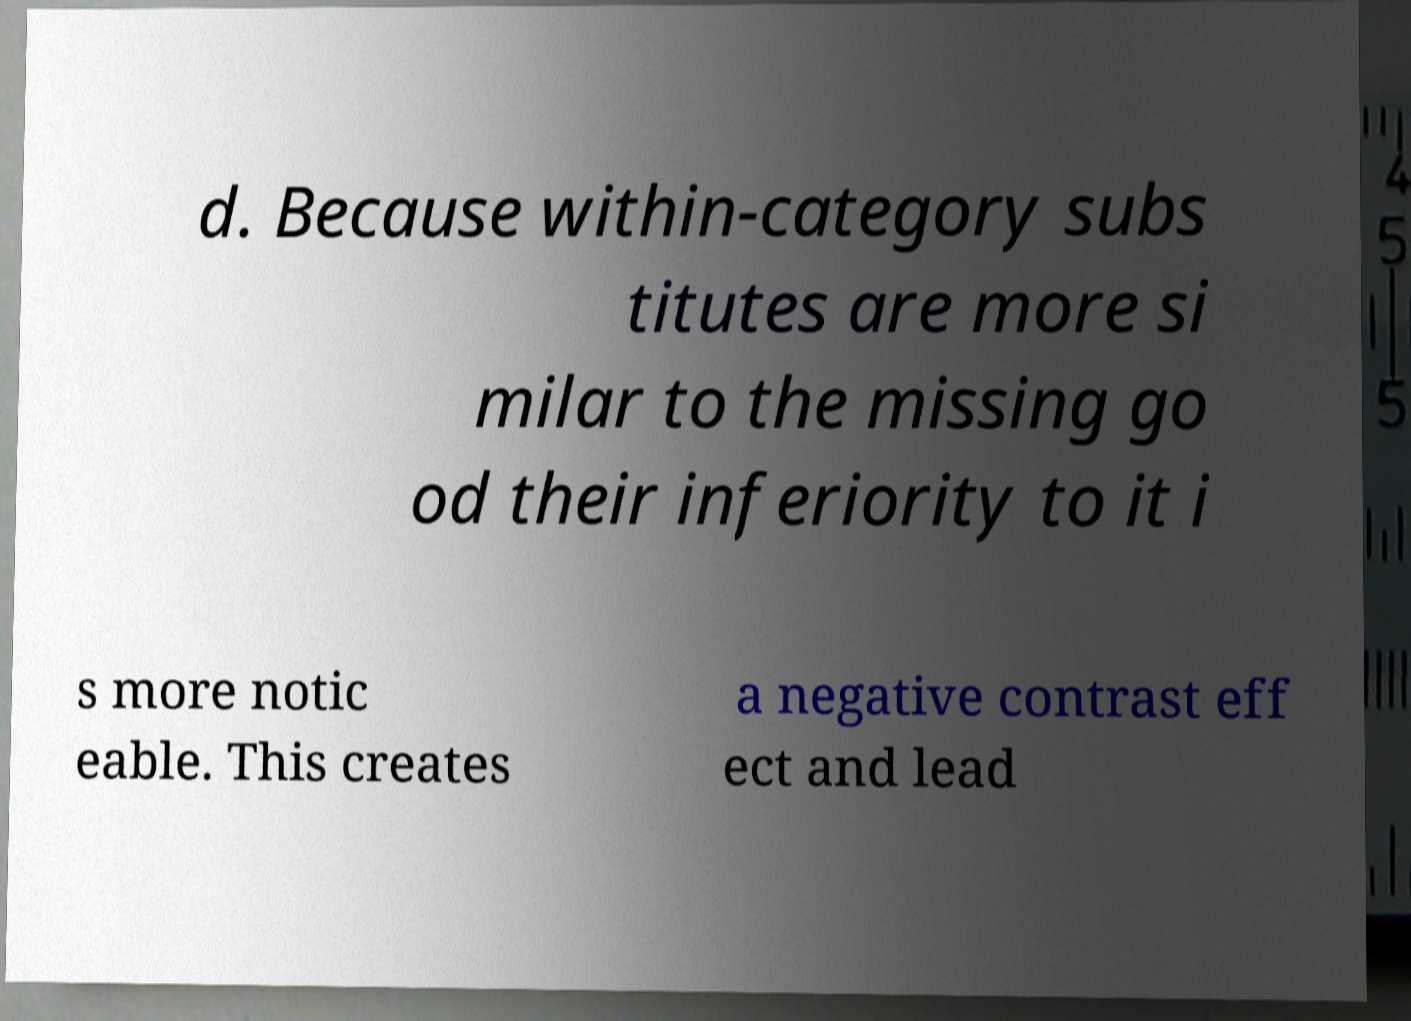Could you extract and type out the text from this image? d. Because within-category subs titutes are more si milar to the missing go od their inferiority to it i s more notic eable. This creates a negative contrast eff ect and lead 